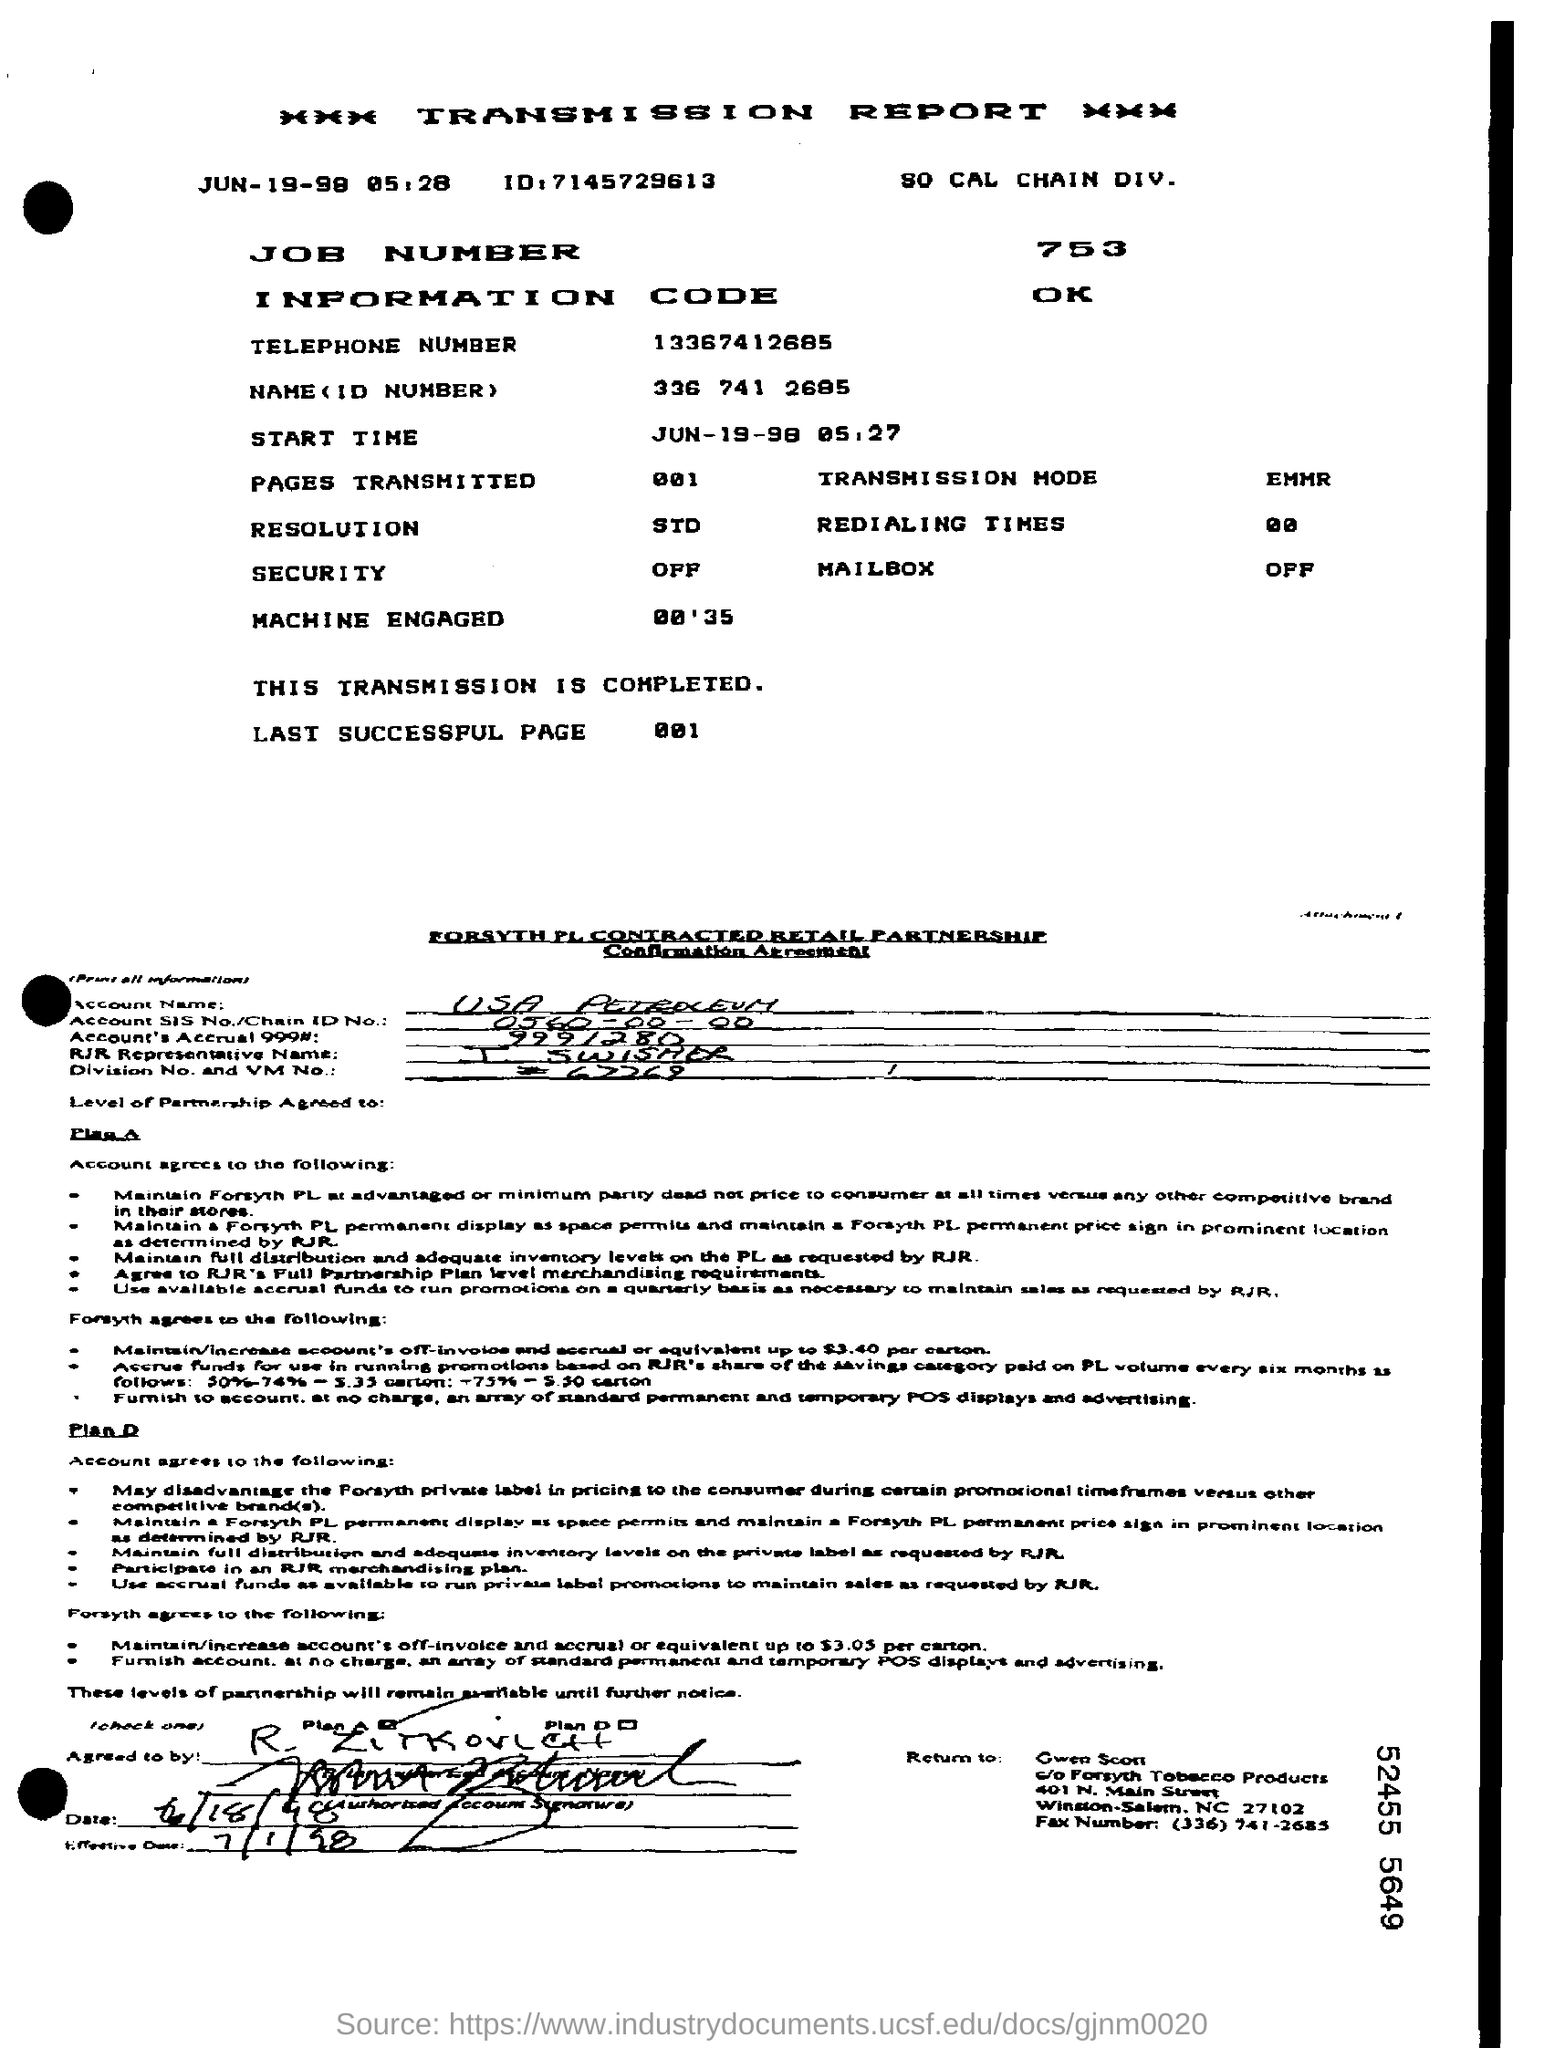What is written in the Letter Head ?
Make the answer very short. Transmission report. What is the job number given?
Provide a short and direct response. 753. What is the ID Number mentioned in the transmission report?
Offer a terse response. 336 741 2685. What is written in the Transmission Mode Field ?
Provide a succinct answer. EMMR. What is mentioned in the Security Field ?
Your response must be concise. Off. What is written in the Mailbox Field ?
Provide a short and direct response. OFF. 